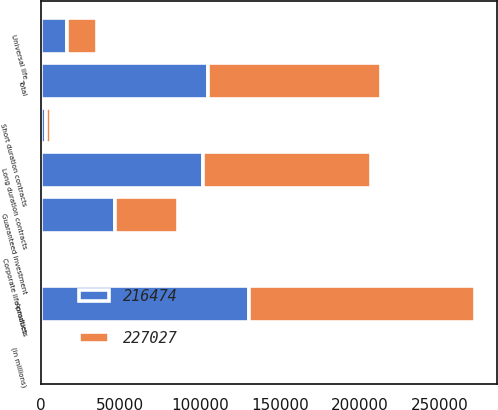Convert chart to OTSL. <chart><loc_0><loc_0><loc_500><loc_500><stacked_bar_chart><ecel><fcel>(in millions)<fcel>Long duration contracts<fcel>Short duration contracts<fcel>Total<fcel>Annuities<fcel>Guaranteed investment<fcel>Corporate life products<fcel>Universal life<nl><fcel>227027<fcel>2005<fcel>105490<fcel>3317<fcel>108807<fcel>142057<fcel>39705<fcel>2077<fcel>18682<nl><fcel>216474<fcel>2004<fcel>101584<fcel>3156<fcel>104740<fcel>130524<fcel>46472<fcel>2042<fcel>16771<nl></chart> 